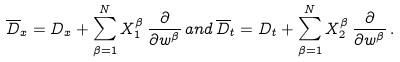Convert formula to latex. <formula><loc_0><loc_0><loc_500><loc_500>\overline { D } _ { x } = D _ { x } + \sum _ { \beta = 1 } ^ { N } X _ { 1 } ^ { \beta } \, \frac { \partial } { \partial w ^ { \beta } } \, a n d \, \overline { D } _ { t } = D _ { t } + \sum _ { \beta = 1 } ^ { N } X _ { 2 } ^ { \beta } \, \frac { \partial } { \partial w ^ { \beta } } \, .</formula> 